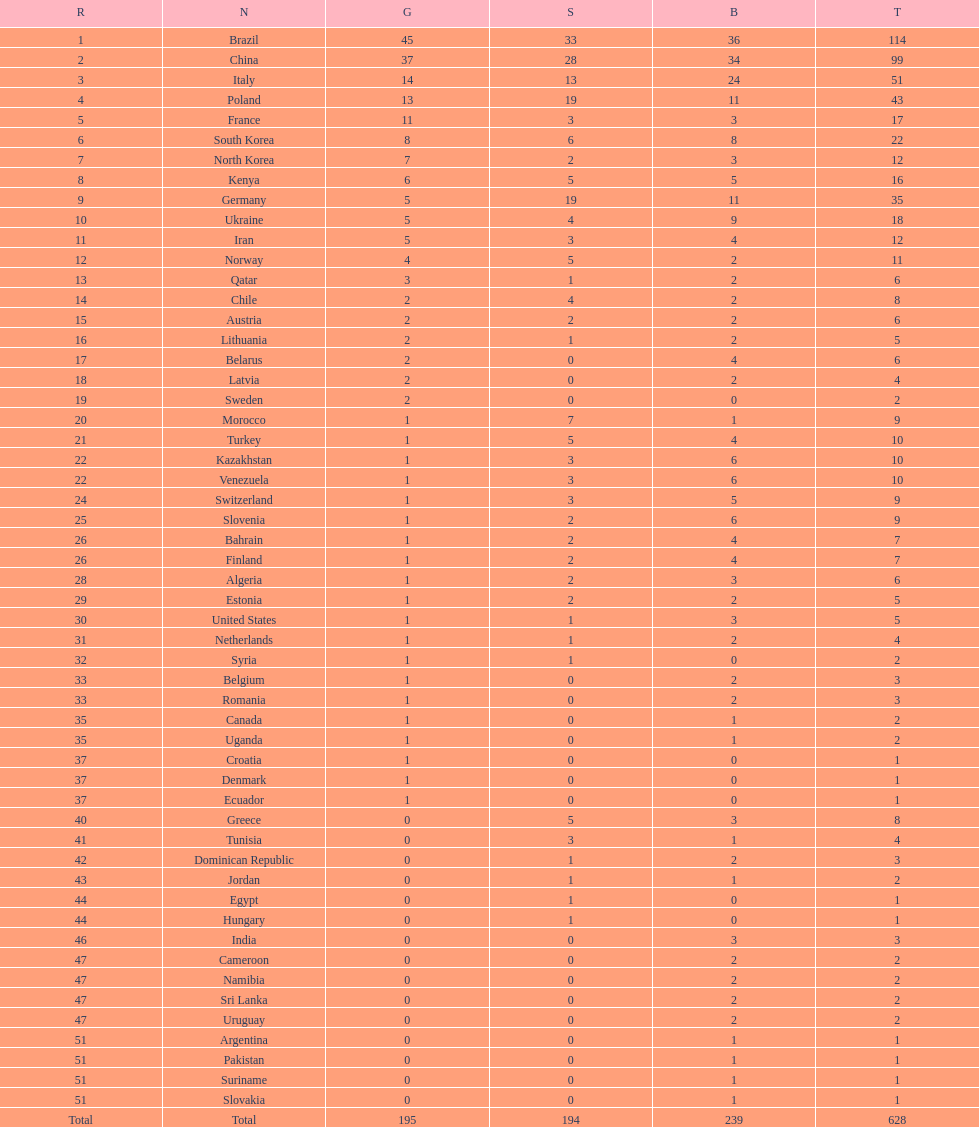How many more gold medals does china have over france? 26. 